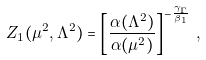Convert formula to latex. <formula><loc_0><loc_0><loc_500><loc_500>Z _ { 1 } ( \mu ^ { 2 } , \Lambda ^ { 2 } ) = \left [ \frac { \alpha ( \Lambda ^ { 2 } ) } { \alpha ( \mu ^ { 2 } ) } \right ] ^ { - \frac { \gamma _ { \Gamma } } { \beta _ { 1 } } } \, ,</formula> 